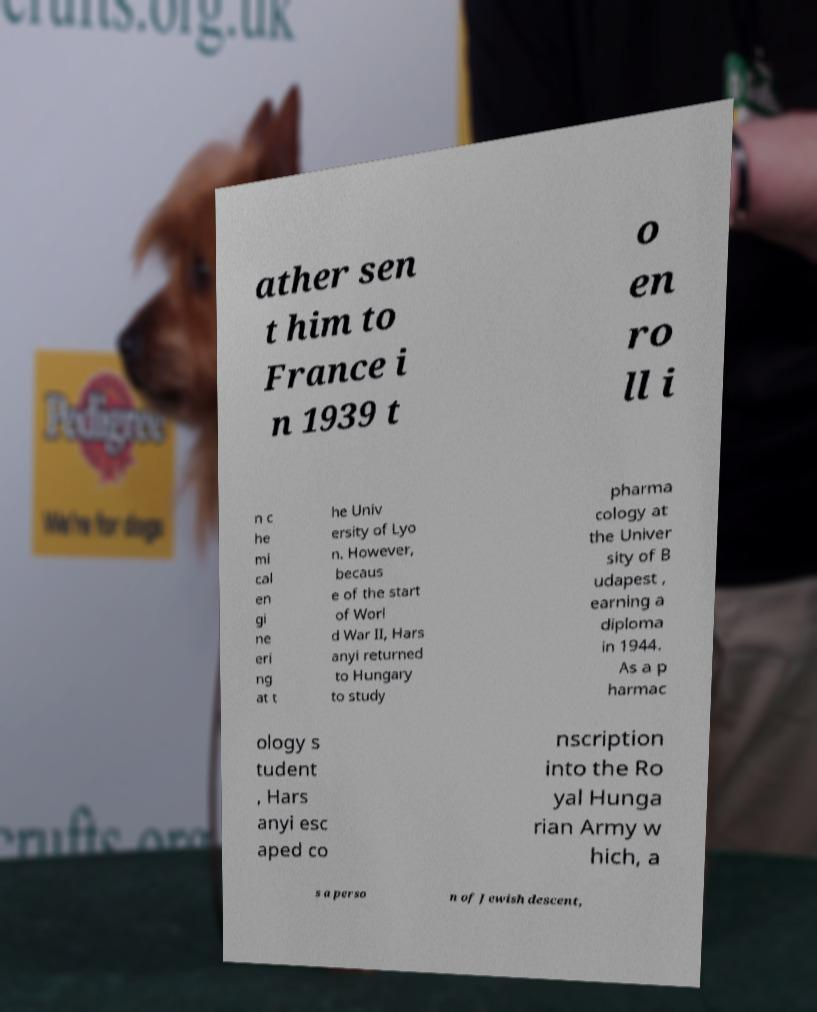Could you extract and type out the text from this image? ather sen t him to France i n 1939 t o en ro ll i n c he mi cal en gi ne eri ng at t he Univ ersity of Lyo n. However, becaus e of the start of Worl d War II, Hars anyi returned to Hungary to study pharma cology at the Univer sity of B udapest , earning a diploma in 1944. As a p harmac ology s tudent , Hars anyi esc aped co nscription into the Ro yal Hunga rian Army w hich, a s a perso n of Jewish descent, 